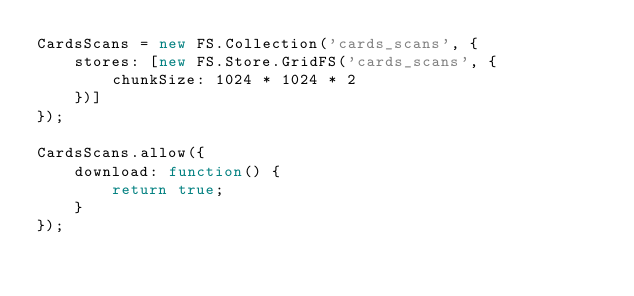<code> <loc_0><loc_0><loc_500><loc_500><_JavaScript_>CardsScans = new FS.Collection('cards_scans', {
    stores: [new FS.Store.GridFS('cards_scans', {
        chunkSize: 1024 * 1024 * 2
    })]
});

CardsScans.allow({
    download: function() {
        return true;
    }
});
</code> 